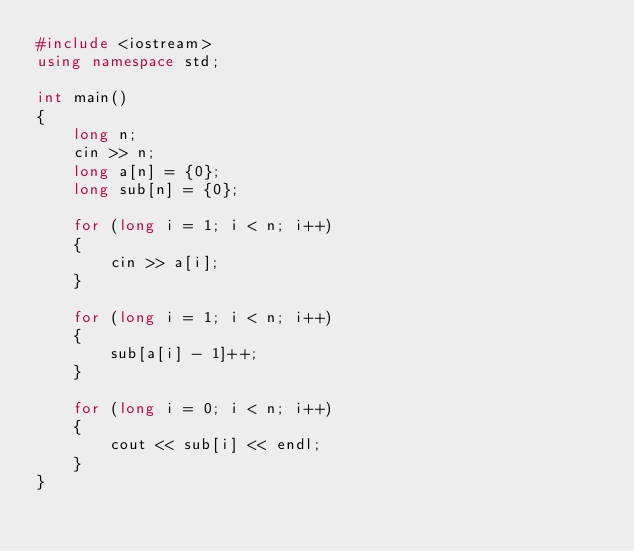Convert code to text. <code><loc_0><loc_0><loc_500><loc_500><_C++_>#include <iostream>
using namespace std;

int main()
{
    long n;
    cin >> n;
    long a[n] = {0};
    long sub[n] = {0};

    for (long i = 1; i < n; i++)
    {
        cin >> a[i];
    }

    for (long i = 1; i < n; i++)
    {
        sub[a[i] - 1]++;
    }

    for (long i = 0; i < n; i++)
    {
        cout << sub[i] << endl;
    }
}
</code> 